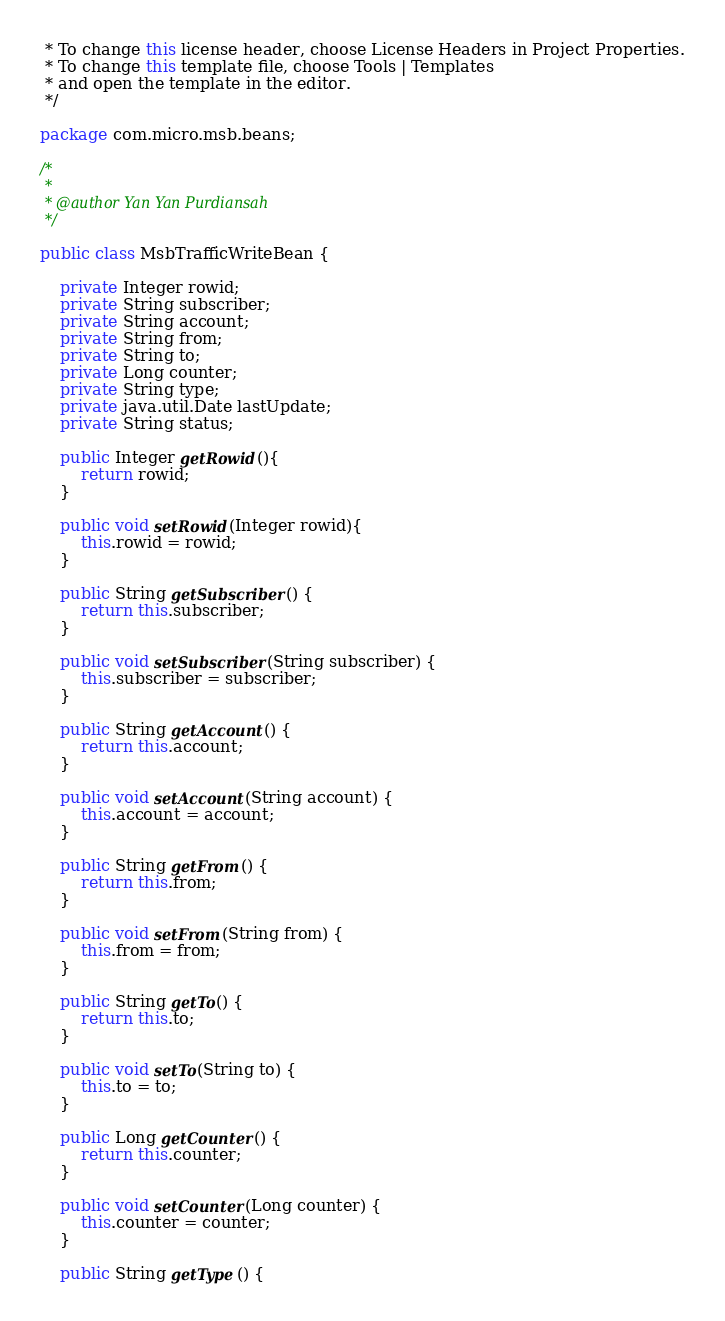<code> <loc_0><loc_0><loc_500><loc_500><_Java_> * To change this license header, choose License Headers in Project Properties.
 * To change this template file, choose Tools | Templates
 * and open the template in the editor.
 */

package com.micro.msb.beans;

/*
 *
 * @author Yan Yan Purdiansah
 */

public class MsbTrafficWriteBean {

    private Integer rowid;
	private String subscriber;
	private String account;
	private String from;
	private String to;
	private Long counter;
	private String type;
	private java.util.Date lastUpdate;
	private String status;

    public Integer getRowid(){
    	return rowid;
    }
    
    public void setRowid(Integer rowid){
    	this.rowid = rowid;
    }
    
	public String getSubscriber() {
    	return this.subscriber;
	}
  
	public void setSubscriber(String subscriber) {
    	this.subscriber = subscriber;
	}

	public String getAccount() {
    	return this.account;
	}
  
	public void setAccount(String account) {
    	this.account = account;
	}

	public String getFrom() {
    	return this.from;
	}
  
	public void setFrom(String from) {
    	this.from = from;
	}

	public String getTo() {
    	return this.to;
	}
  
	public void setTo(String to) {
    	this.to = to;
	}

	public Long getCounter() {
    	return this.counter;
	}
  
	public void setCounter(Long counter) {
    	this.counter = counter;
	}

	public String getType() {</code> 